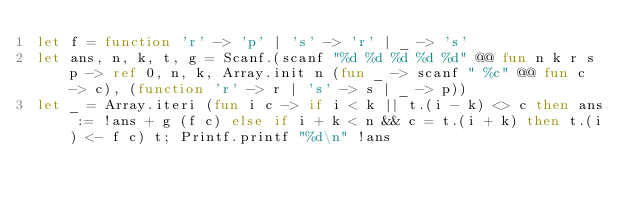Convert code to text. <code><loc_0><loc_0><loc_500><loc_500><_OCaml_>let f = function 'r' -> 'p' | 's' -> 'r' | _ -> 's'
let ans, n, k, t, g = Scanf.(scanf "%d %d %d %d %d" @@ fun n k r s p -> ref 0, n, k, Array.init n (fun _ -> scanf " %c" @@ fun c -> c), (function 'r' -> r | 's' -> s | _ -> p))
let _ = Array.iteri (fun i c -> if i < k || t.(i - k) <> c then ans := !ans + g (f c) else if i + k < n && c = t.(i + k) then t.(i) <- f c) t; Printf.printf "%d\n" !ans</code> 